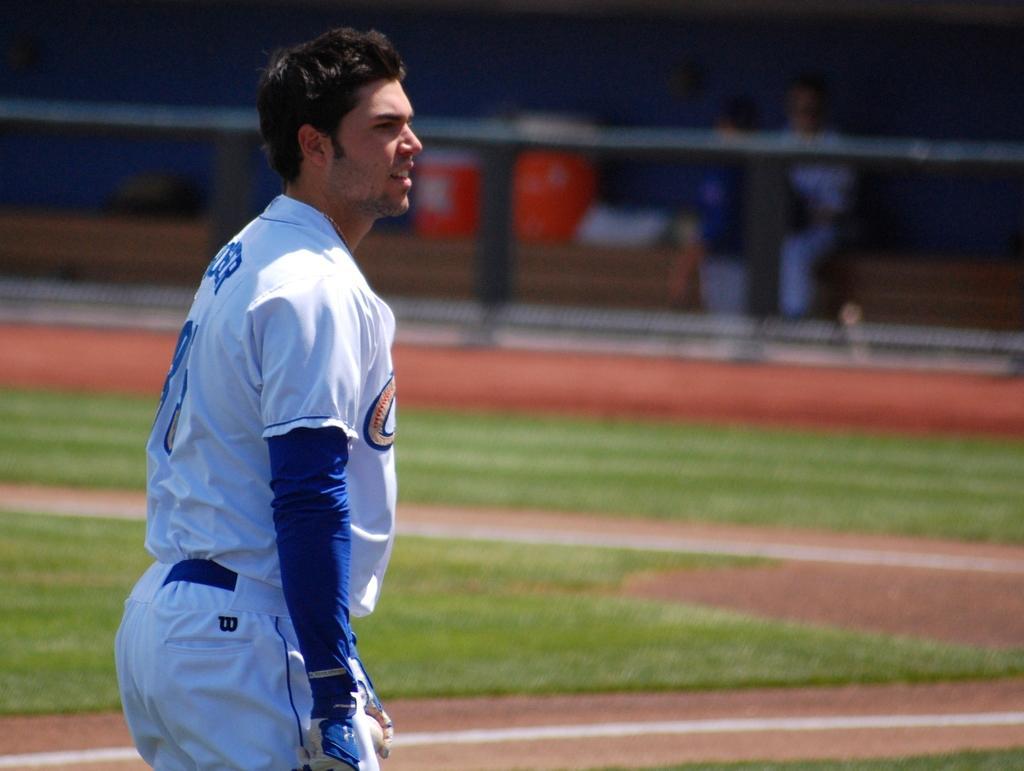Please provide a concise description of this image. In this image in front there is a person. At the bottom of the image there is grass on the surface. There is a fence. In the background of the image there are two people sitting on the stairs. Beside them there are two dustbins. 